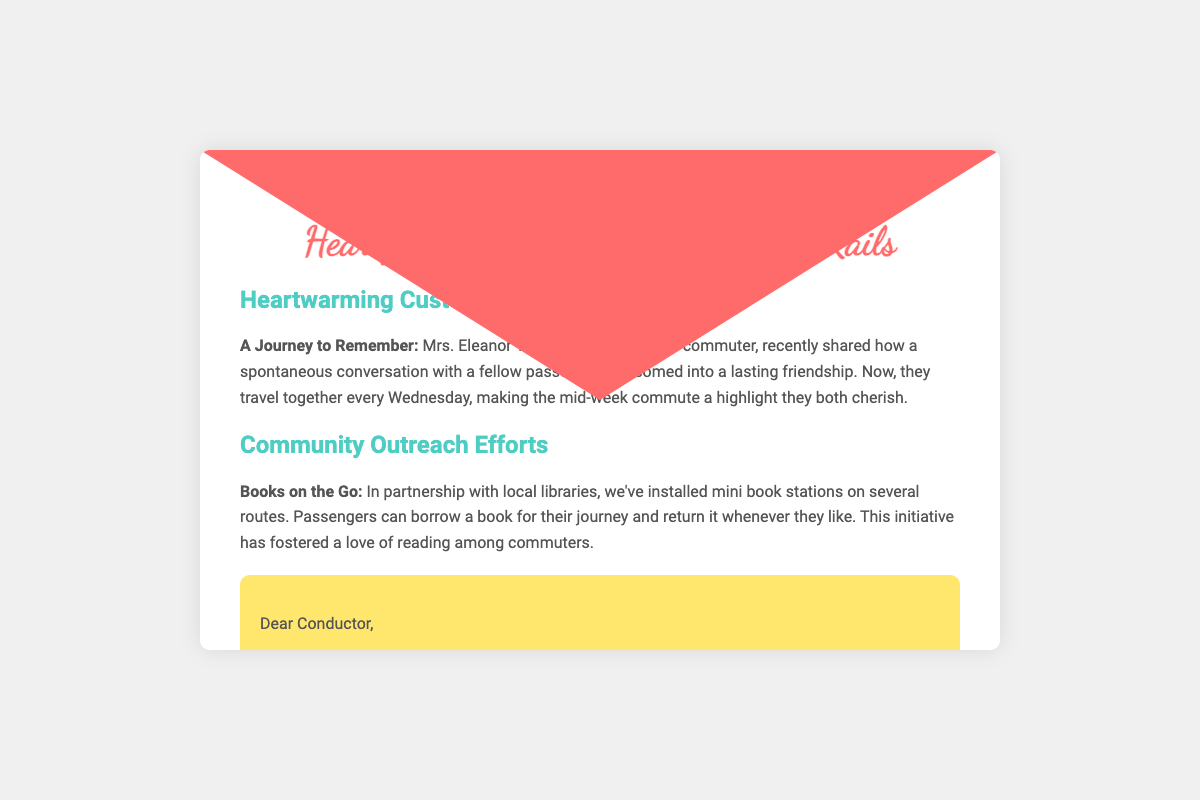what is the title of the newsletter? The title of the newsletter is prominently displayed at the top of the document.
Answer: Heartfelt Journeys: Stories from the Rails who is highlighted in the customer experience story? The customer experience story features a specific individual who shared a memorable experience.
Answer: Mrs. Eleanor Thompson what recent initiative is mentioned in the community outreach efforts? The document outlines an initiative that partners with local libraries for commuters.
Answer: Books on the Go how has the conductor's service been acknowledged in the newsletter? The newsletter includes a section expressing appreciation for the conductor's work.
Answer: Thank you for being a beacon of positivity what item is positioned at the bottom right of the envelope? The envelope includes an icon that represents the essence of the train journey.
Answer: 🚂 